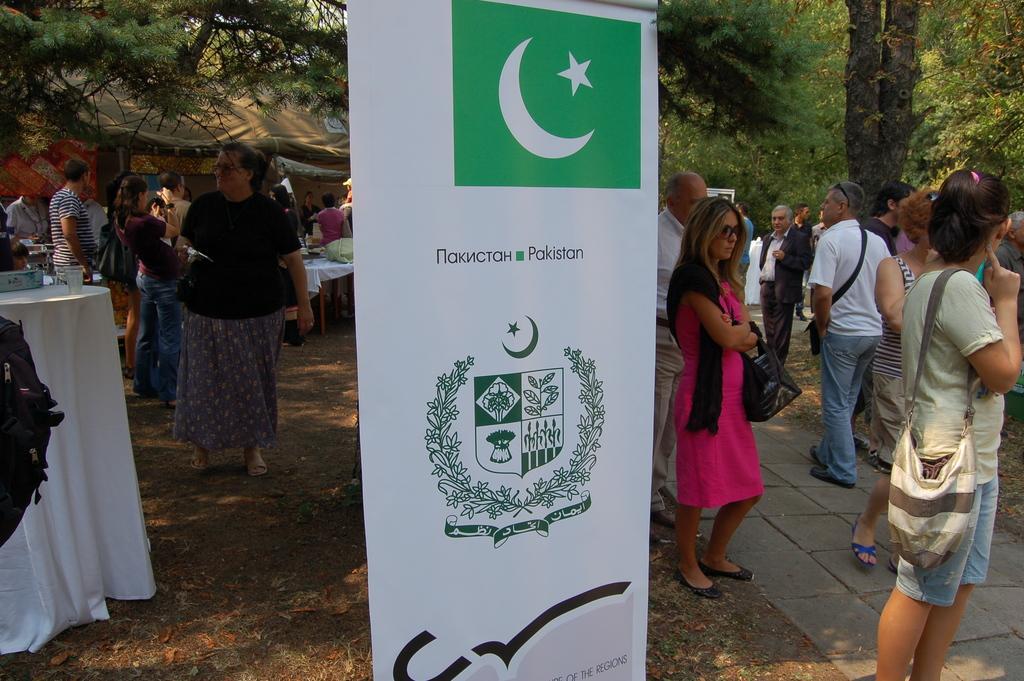Please provide a concise description of this image. In this picture we can see the white and green rolling banner in the front. Behind there are some men and women standing in the ground. In the background there are some trees. 